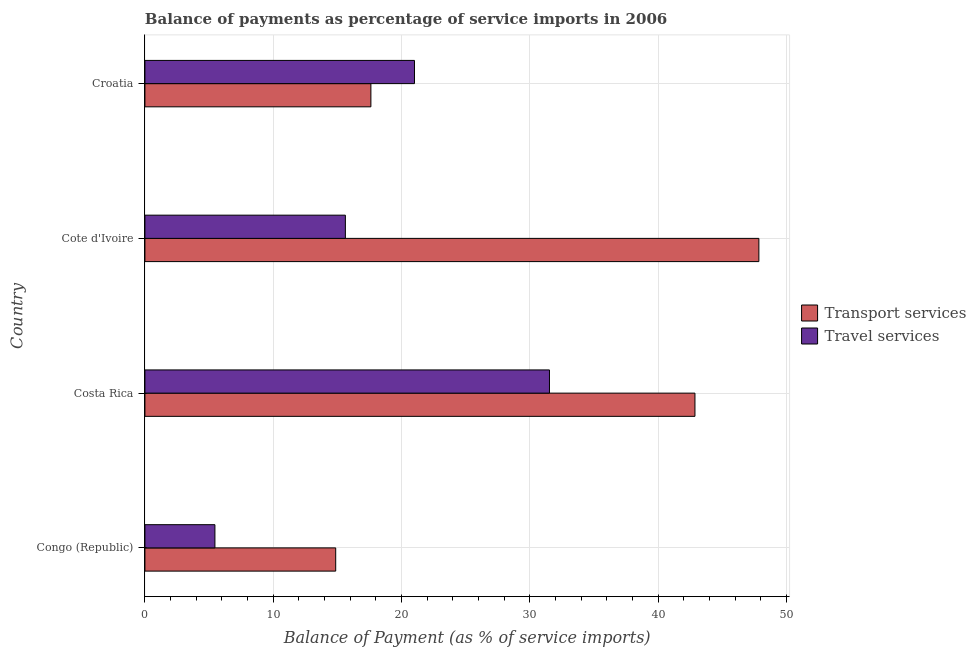How many groups of bars are there?
Your answer should be very brief. 4. Are the number of bars on each tick of the Y-axis equal?
Your response must be concise. Yes. How many bars are there on the 1st tick from the bottom?
Keep it short and to the point. 2. What is the label of the 3rd group of bars from the top?
Keep it short and to the point. Costa Rica. In how many cases, is the number of bars for a given country not equal to the number of legend labels?
Provide a short and direct response. 0. What is the balance of payments of travel services in Croatia?
Your answer should be very brief. 21.01. Across all countries, what is the maximum balance of payments of transport services?
Provide a short and direct response. 47.85. Across all countries, what is the minimum balance of payments of travel services?
Your response must be concise. 5.46. In which country was the balance of payments of travel services maximum?
Provide a succinct answer. Costa Rica. In which country was the balance of payments of travel services minimum?
Give a very brief answer. Congo (Republic). What is the total balance of payments of transport services in the graph?
Provide a succinct answer. 123.19. What is the difference between the balance of payments of travel services in Costa Rica and that in Cote d'Ivoire?
Offer a terse response. 15.9. What is the difference between the balance of payments of transport services in Croatia and the balance of payments of travel services in Congo (Republic)?
Offer a terse response. 12.16. What is the average balance of payments of transport services per country?
Offer a terse response. 30.8. What is the difference between the balance of payments of transport services and balance of payments of travel services in Croatia?
Make the answer very short. -3.4. In how many countries, is the balance of payments of travel services greater than 24 %?
Give a very brief answer. 1. What is the ratio of the balance of payments of travel services in Congo (Republic) to that in Cote d'Ivoire?
Your answer should be compact. 0.35. Is the balance of payments of transport services in Costa Rica less than that in Croatia?
Keep it short and to the point. No. Is the difference between the balance of payments of transport services in Congo (Republic) and Croatia greater than the difference between the balance of payments of travel services in Congo (Republic) and Croatia?
Ensure brevity in your answer.  Yes. What is the difference between the highest and the second highest balance of payments of transport services?
Your answer should be very brief. 4.98. What is the difference between the highest and the lowest balance of payments of travel services?
Your answer should be compact. 26.07. Is the sum of the balance of payments of travel services in Congo (Republic) and Costa Rica greater than the maximum balance of payments of transport services across all countries?
Give a very brief answer. No. What does the 1st bar from the top in Cote d'Ivoire represents?
Make the answer very short. Travel services. What does the 2nd bar from the bottom in Cote d'Ivoire represents?
Offer a terse response. Travel services. Are the values on the major ticks of X-axis written in scientific E-notation?
Your answer should be compact. No. Does the graph contain any zero values?
Your answer should be compact. No. Does the graph contain grids?
Offer a terse response. Yes. How are the legend labels stacked?
Provide a succinct answer. Vertical. What is the title of the graph?
Ensure brevity in your answer.  Balance of payments as percentage of service imports in 2006. Does "Services" appear as one of the legend labels in the graph?
Give a very brief answer. No. What is the label or title of the X-axis?
Your response must be concise. Balance of Payment (as % of service imports). What is the Balance of Payment (as % of service imports) of Transport services in Congo (Republic)?
Your answer should be very brief. 14.87. What is the Balance of Payment (as % of service imports) in Travel services in Congo (Republic)?
Your answer should be very brief. 5.46. What is the Balance of Payment (as % of service imports) of Transport services in Costa Rica?
Keep it short and to the point. 42.87. What is the Balance of Payment (as % of service imports) in Travel services in Costa Rica?
Provide a succinct answer. 31.53. What is the Balance of Payment (as % of service imports) of Transport services in Cote d'Ivoire?
Provide a succinct answer. 47.85. What is the Balance of Payment (as % of service imports) of Travel services in Cote d'Ivoire?
Your answer should be compact. 15.62. What is the Balance of Payment (as % of service imports) in Transport services in Croatia?
Offer a terse response. 17.61. What is the Balance of Payment (as % of service imports) of Travel services in Croatia?
Make the answer very short. 21.01. Across all countries, what is the maximum Balance of Payment (as % of service imports) of Transport services?
Ensure brevity in your answer.  47.85. Across all countries, what is the maximum Balance of Payment (as % of service imports) in Travel services?
Your answer should be compact. 31.53. Across all countries, what is the minimum Balance of Payment (as % of service imports) in Transport services?
Make the answer very short. 14.87. Across all countries, what is the minimum Balance of Payment (as % of service imports) of Travel services?
Keep it short and to the point. 5.46. What is the total Balance of Payment (as % of service imports) of Transport services in the graph?
Ensure brevity in your answer.  123.19. What is the total Balance of Payment (as % of service imports) of Travel services in the graph?
Your response must be concise. 73.61. What is the difference between the Balance of Payment (as % of service imports) of Transport services in Congo (Republic) and that in Costa Rica?
Provide a short and direct response. -28. What is the difference between the Balance of Payment (as % of service imports) in Travel services in Congo (Republic) and that in Costa Rica?
Offer a terse response. -26.07. What is the difference between the Balance of Payment (as % of service imports) in Transport services in Congo (Republic) and that in Cote d'Ivoire?
Your response must be concise. -32.98. What is the difference between the Balance of Payment (as % of service imports) of Travel services in Congo (Republic) and that in Cote d'Ivoire?
Offer a very short reply. -10.17. What is the difference between the Balance of Payment (as % of service imports) of Transport services in Congo (Republic) and that in Croatia?
Provide a short and direct response. -2.74. What is the difference between the Balance of Payment (as % of service imports) in Travel services in Congo (Republic) and that in Croatia?
Offer a terse response. -15.55. What is the difference between the Balance of Payment (as % of service imports) in Transport services in Costa Rica and that in Cote d'Ivoire?
Provide a succinct answer. -4.98. What is the difference between the Balance of Payment (as % of service imports) in Travel services in Costa Rica and that in Cote d'Ivoire?
Keep it short and to the point. 15.91. What is the difference between the Balance of Payment (as % of service imports) of Transport services in Costa Rica and that in Croatia?
Offer a terse response. 25.26. What is the difference between the Balance of Payment (as % of service imports) in Travel services in Costa Rica and that in Croatia?
Offer a very short reply. 10.52. What is the difference between the Balance of Payment (as % of service imports) of Transport services in Cote d'Ivoire and that in Croatia?
Offer a terse response. 30.24. What is the difference between the Balance of Payment (as % of service imports) in Travel services in Cote d'Ivoire and that in Croatia?
Ensure brevity in your answer.  -5.39. What is the difference between the Balance of Payment (as % of service imports) of Transport services in Congo (Republic) and the Balance of Payment (as % of service imports) of Travel services in Costa Rica?
Ensure brevity in your answer.  -16.66. What is the difference between the Balance of Payment (as % of service imports) of Transport services in Congo (Republic) and the Balance of Payment (as % of service imports) of Travel services in Cote d'Ivoire?
Give a very brief answer. -0.75. What is the difference between the Balance of Payment (as % of service imports) of Transport services in Congo (Republic) and the Balance of Payment (as % of service imports) of Travel services in Croatia?
Ensure brevity in your answer.  -6.14. What is the difference between the Balance of Payment (as % of service imports) of Transport services in Costa Rica and the Balance of Payment (as % of service imports) of Travel services in Cote d'Ivoire?
Offer a terse response. 27.24. What is the difference between the Balance of Payment (as % of service imports) of Transport services in Costa Rica and the Balance of Payment (as % of service imports) of Travel services in Croatia?
Offer a terse response. 21.86. What is the difference between the Balance of Payment (as % of service imports) in Transport services in Cote d'Ivoire and the Balance of Payment (as % of service imports) in Travel services in Croatia?
Your answer should be compact. 26.84. What is the average Balance of Payment (as % of service imports) in Transport services per country?
Your answer should be very brief. 30.8. What is the average Balance of Payment (as % of service imports) in Travel services per country?
Keep it short and to the point. 18.4. What is the difference between the Balance of Payment (as % of service imports) of Transport services and Balance of Payment (as % of service imports) of Travel services in Congo (Republic)?
Give a very brief answer. 9.41. What is the difference between the Balance of Payment (as % of service imports) in Transport services and Balance of Payment (as % of service imports) in Travel services in Costa Rica?
Provide a short and direct response. 11.34. What is the difference between the Balance of Payment (as % of service imports) in Transport services and Balance of Payment (as % of service imports) in Travel services in Cote d'Ivoire?
Make the answer very short. 32.23. What is the difference between the Balance of Payment (as % of service imports) in Transport services and Balance of Payment (as % of service imports) in Travel services in Croatia?
Your answer should be very brief. -3.4. What is the ratio of the Balance of Payment (as % of service imports) of Transport services in Congo (Republic) to that in Costa Rica?
Ensure brevity in your answer.  0.35. What is the ratio of the Balance of Payment (as % of service imports) of Travel services in Congo (Republic) to that in Costa Rica?
Ensure brevity in your answer.  0.17. What is the ratio of the Balance of Payment (as % of service imports) of Transport services in Congo (Republic) to that in Cote d'Ivoire?
Your response must be concise. 0.31. What is the ratio of the Balance of Payment (as % of service imports) of Travel services in Congo (Republic) to that in Cote d'Ivoire?
Provide a short and direct response. 0.35. What is the ratio of the Balance of Payment (as % of service imports) in Transport services in Congo (Republic) to that in Croatia?
Give a very brief answer. 0.84. What is the ratio of the Balance of Payment (as % of service imports) of Travel services in Congo (Republic) to that in Croatia?
Provide a succinct answer. 0.26. What is the ratio of the Balance of Payment (as % of service imports) in Transport services in Costa Rica to that in Cote d'Ivoire?
Provide a succinct answer. 0.9. What is the ratio of the Balance of Payment (as % of service imports) in Travel services in Costa Rica to that in Cote d'Ivoire?
Give a very brief answer. 2.02. What is the ratio of the Balance of Payment (as % of service imports) in Transport services in Costa Rica to that in Croatia?
Provide a short and direct response. 2.43. What is the ratio of the Balance of Payment (as % of service imports) of Travel services in Costa Rica to that in Croatia?
Offer a terse response. 1.5. What is the ratio of the Balance of Payment (as % of service imports) in Transport services in Cote d'Ivoire to that in Croatia?
Provide a short and direct response. 2.72. What is the ratio of the Balance of Payment (as % of service imports) of Travel services in Cote d'Ivoire to that in Croatia?
Ensure brevity in your answer.  0.74. What is the difference between the highest and the second highest Balance of Payment (as % of service imports) of Transport services?
Give a very brief answer. 4.98. What is the difference between the highest and the second highest Balance of Payment (as % of service imports) of Travel services?
Your response must be concise. 10.52. What is the difference between the highest and the lowest Balance of Payment (as % of service imports) of Transport services?
Offer a very short reply. 32.98. What is the difference between the highest and the lowest Balance of Payment (as % of service imports) of Travel services?
Provide a short and direct response. 26.07. 